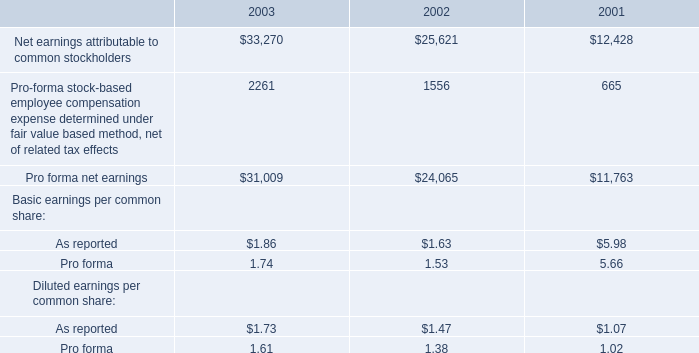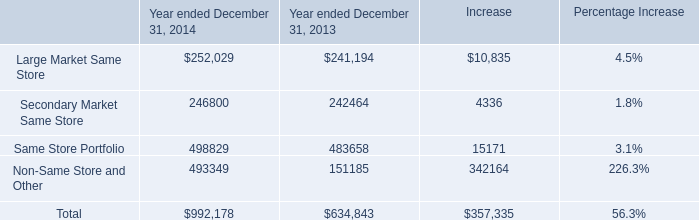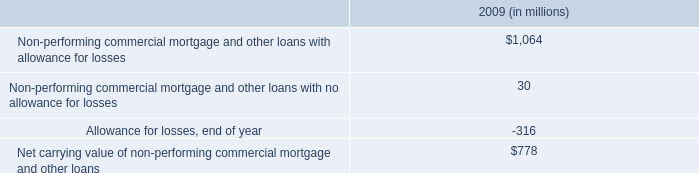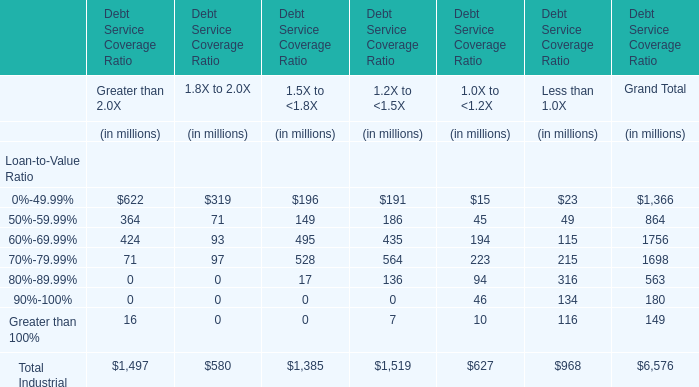What is the percentage of all 1.5X to <1.8X that are positive to the total amount, in Debt Service Coverage Ratio? 
Computations: (((((((196 + 149) + 495) + 528) + 17) + 0) + 0) / 1385)
Answer: 1.0. 